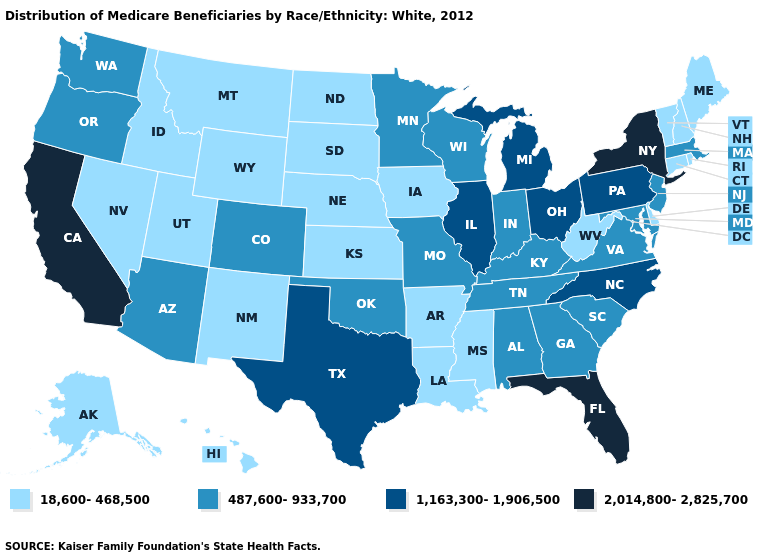Among the states that border California , which have the lowest value?
Give a very brief answer. Nevada. Among the states that border Maryland , which have the lowest value?
Give a very brief answer. Delaware, West Virginia. Among the states that border Ohio , does Indiana have the highest value?
Short answer required. No. Name the states that have a value in the range 1,163,300-1,906,500?
Quick response, please. Illinois, Michigan, North Carolina, Ohio, Pennsylvania, Texas. Name the states that have a value in the range 2,014,800-2,825,700?
Concise answer only. California, Florida, New York. Among the states that border Wisconsin , which have the highest value?
Quick response, please. Illinois, Michigan. Does Indiana have the lowest value in the USA?
Quick response, please. No. Is the legend a continuous bar?
Concise answer only. No. What is the value of New Hampshire?
Be succinct. 18,600-468,500. What is the value of Florida?
Give a very brief answer. 2,014,800-2,825,700. What is the value of Colorado?
Keep it brief. 487,600-933,700. Does Oregon have a lower value than Texas?
Give a very brief answer. Yes. What is the value of Minnesota?
Write a very short answer. 487,600-933,700. Name the states that have a value in the range 1,163,300-1,906,500?
Quick response, please. Illinois, Michigan, North Carolina, Ohio, Pennsylvania, Texas. What is the value of Nebraska?
Short answer required. 18,600-468,500. 